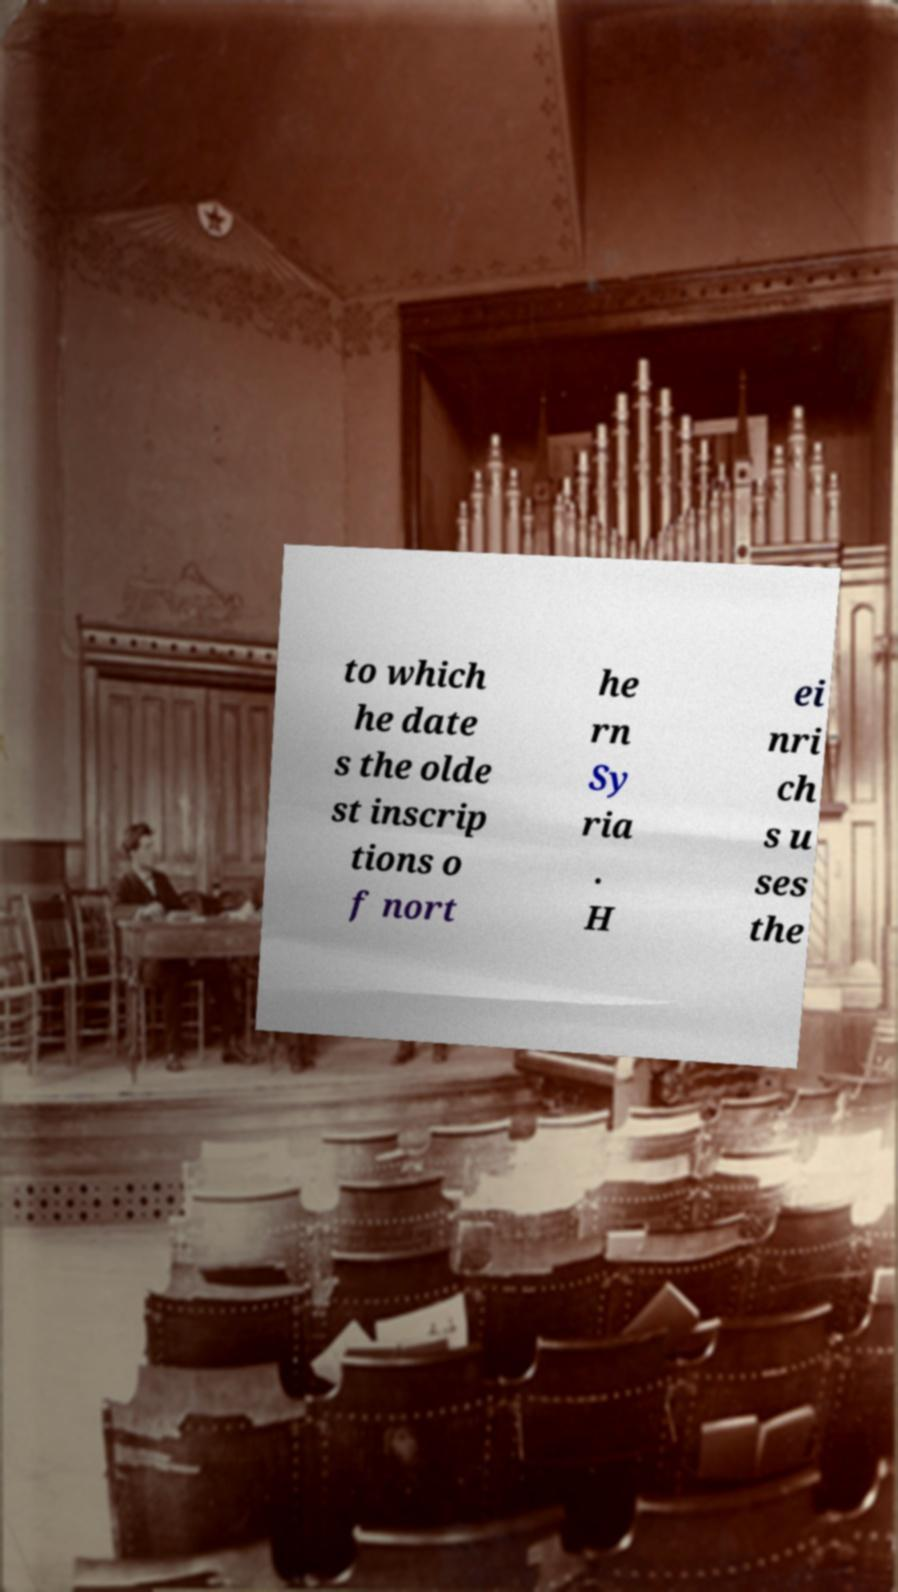Could you assist in decoding the text presented in this image and type it out clearly? to which he date s the olde st inscrip tions o f nort he rn Sy ria . H ei nri ch s u ses the 